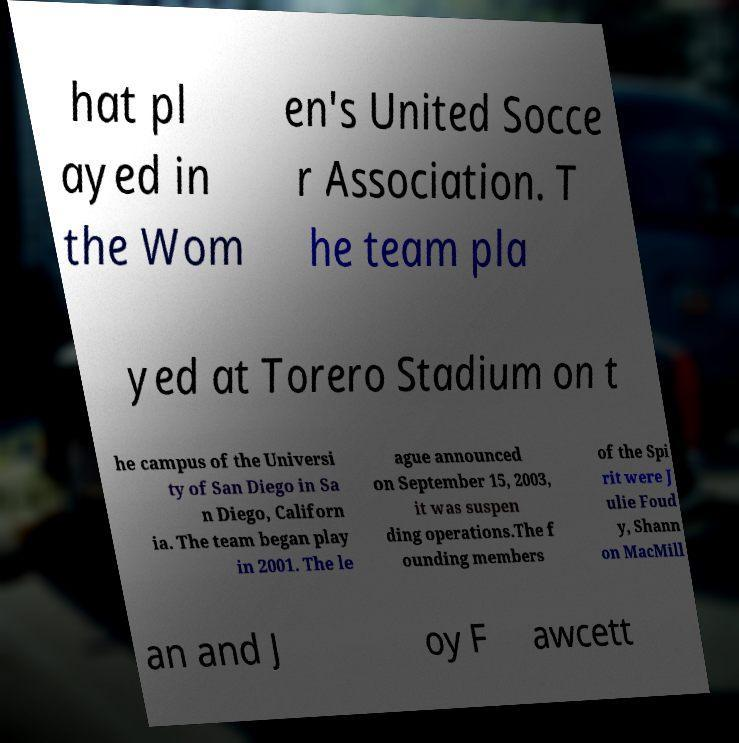I need the written content from this picture converted into text. Can you do that? hat pl ayed in the Wom en's United Socce r Association. T he team pla yed at Torero Stadium on t he campus of the Universi ty of San Diego in Sa n Diego, Californ ia. The team began play in 2001. The le ague announced on September 15, 2003, it was suspen ding operations.The f ounding members of the Spi rit were J ulie Foud y, Shann on MacMill an and J oy F awcett 